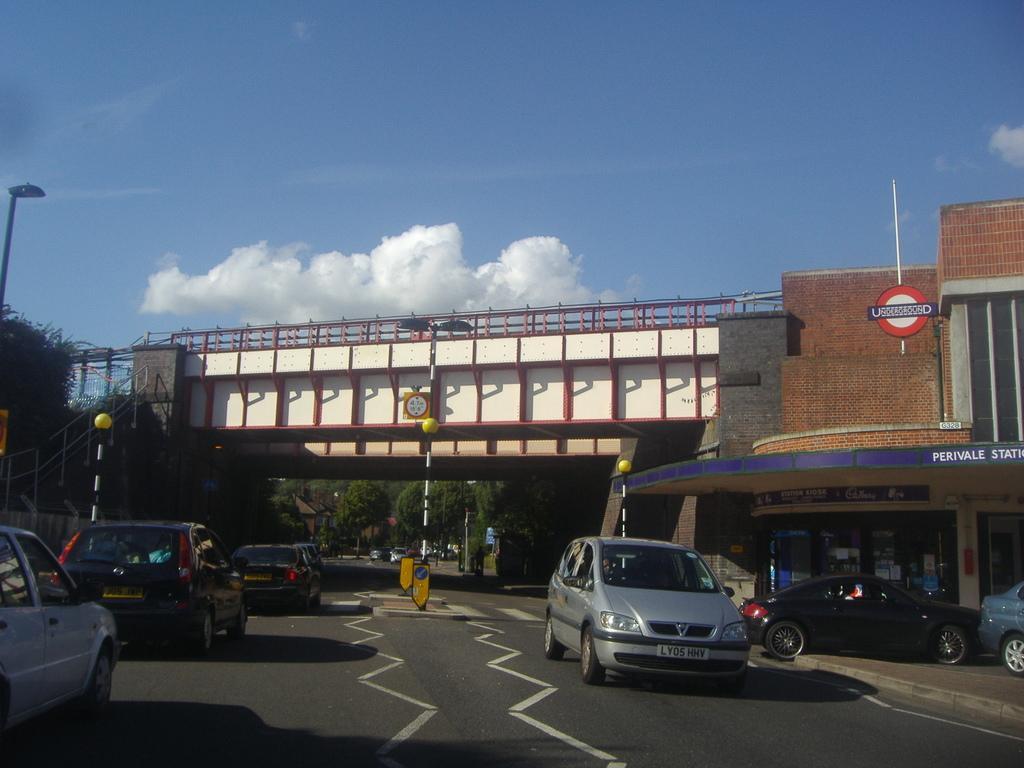Can you describe this image briefly? As we can see in the image there are buildings, different colors of cars, street lamps, poles and trees. There is a bridge. At the top there is sky and there are clouds. 